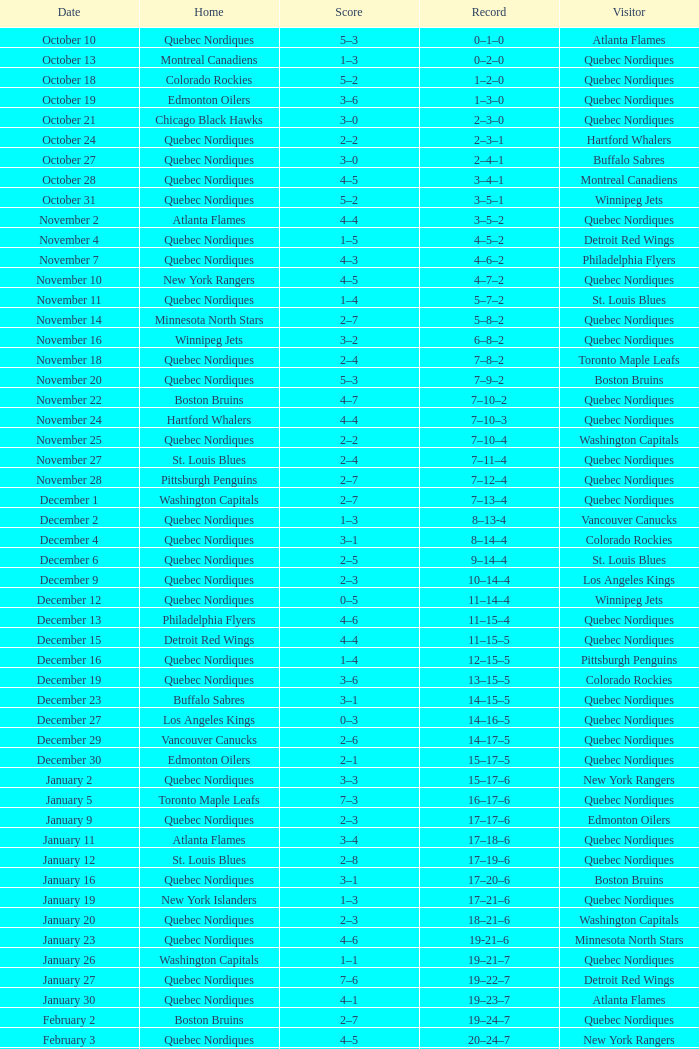Could you parse the entire table as a dict? {'header': ['Date', 'Home', 'Score', 'Record', 'Visitor'], 'rows': [['October 10', 'Quebec Nordiques', '5–3', '0–1–0', 'Atlanta Flames'], ['October 13', 'Montreal Canadiens', '1–3', '0–2–0', 'Quebec Nordiques'], ['October 18', 'Colorado Rockies', '5–2', '1–2–0', 'Quebec Nordiques'], ['October 19', 'Edmonton Oilers', '3–6', '1–3–0', 'Quebec Nordiques'], ['October 21', 'Chicago Black Hawks', '3–0', '2–3–0', 'Quebec Nordiques'], ['October 24', 'Quebec Nordiques', '2–2', '2–3–1', 'Hartford Whalers'], ['October 27', 'Quebec Nordiques', '3–0', '2–4–1', 'Buffalo Sabres'], ['October 28', 'Quebec Nordiques', '4–5', '3–4–1', 'Montreal Canadiens'], ['October 31', 'Quebec Nordiques', '5–2', '3–5–1', 'Winnipeg Jets'], ['November 2', 'Atlanta Flames', '4–4', '3–5–2', 'Quebec Nordiques'], ['November 4', 'Quebec Nordiques', '1–5', '4–5–2', 'Detroit Red Wings'], ['November 7', 'Quebec Nordiques', '4–3', '4–6–2', 'Philadelphia Flyers'], ['November 10', 'New York Rangers', '4–5', '4–7–2', 'Quebec Nordiques'], ['November 11', 'Quebec Nordiques', '1–4', '5–7–2', 'St. Louis Blues'], ['November 14', 'Minnesota North Stars', '2–7', '5–8–2', 'Quebec Nordiques'], ['November 16', 'Winnipeg Jets', '3–2', '6–8–2', 'Quebec Nordiques'], ['November 18', 'Quebec Nordiques', '2–4', '7–8–2', 'Toronto Maple Leafs'], ['November 20', 'Quebec Nordiques', '5–3', '7–9–2', 'Boston Bruins'], ['November 22', 'Boston Bruins', '4–7', '7–10–2', 'Quebec Nordiques'], ['November 24', 'Hartford Whalers', '4–4', '7–10–3', 'Quebec Nordiques'], ['November 25', 'Quebec Nordiques', '2–2', '7–10–4', 'Washington Capitals'], ['November 27', 'St. Louis Blues', '2–4', '7–11–4', 'Quebec Nordiques'], ['November 28', 'Pittsburgh Penguins', '2–7', '7–12–4', 'Quebec Nordiques'], ['December 1', 'Washington Capitals', '2–7', '7–13–4', 'Quebec Nordiques'], ['December 2', 'Quebec Nordiques', '1–3', '8–13-4', 'Vancouver Canucks'], ['December 4', 'Quebec Nordiques', '3–1', '8–14–4', 'Colorado Rockies'], ['December 6', 'Quebec Nordiques', '2–5', '9–14–4', 'St. Louis Blues'], ['December 9', 'Quebec Nordiques', '2–3', '10–14–4', 'Los Angeles Kings'], ['December 12', 'Quebec Nordiques', '0–5', '11–14–4', 'Winnipeg Jets'], ['December 13', 'Philadelphia Flyers', '4–6', '11–15–4', 'Quebec Nordiques'], ['December 15', 'Detroit Red Wings', '4–4', '11–15–5', 'Quebec Nordiques'], ['December 16', 'Quebec Nordiques', '1–4', '12–15–5', 'Pittsburgh Penguins'], ['December 19', 'Quebec Nordiques', '3–6', '13–15–5', 'Colorado Rockies'], ['December 23', 'Buffalo Sabres', '3–1', '14–15–5', 'Quebec Nordiques'], ['December 27', 'Los Angeles Kings', '0–3', '14–16–5', 'Quebec Nordiques'], ['December 29', 'Vancouver Canucks', '2–6', '14–17–5', 'Quebec Nordiques'], ['December 30', 'Edmonton Oilers', '2–1', '15–17–5', 'Quebec Nordiques'], ['January 2', 'Quebec Nordiques', '3–3', '15–17–6', 'New York Rangers'], ['January 5', 'Toronto Maple Leafs', '7–3', '16–17–6', 'Quebec Nordiques'], ['January 9', 'Quebec Nordiques', '2–3', '17–17–6', 'Edmonton Oilers'], ['January 11', 'Atlanta Flames', '3–4', '17–18–6', 'Quebec Nordiques'], ['January 12', 'St. Louis Blues', '2–8', '17–19–6', 'Quebec Nordiques'], ['January 16', 'Quebec Nordiques', '3–1', '17–20–6', 'Boston Bruins'], ['January 19', 'New York Islanders', '1–3', '17–21–6', 'Quebec Nordiques'], ['January 20', 'Quebec Nordiques', '2–3', '18–21–6', 'Washington Capitals'], ['January 23', 'Quebec Nordiques', '4–6', '19-21–6', 'Minnesota North Stars'], ['January 26', 'Washington Capitals', '1–1', '19–21–7', 'Quebec Nordiques'], ['January 27', 'Quebec Nordiques', '7–6', '19–22–7', 'Detroit Red Wings'], ['January 30', 'Quebec Nordiques', '4–1', '19–23–7', 'Atlanta Flames'], ['February 2', 'Boston Bruins', '2–7', '19–24–7', 'Quebec Nordiques'], ['February 3', 'Quebec Nordiques', '4–5', '20–24–7', 'New York Rangers'], ['February 6', 'Quebec Nordiques', '3–3', '20–24–8', 'Chicago Black Hawks'], ['February 9', 'New York Islanders', '0–5', '20–25–8', 'Quebec Nordiques'], ['February 10', 'New York Rangers', '1–3', '20–26–8', 'Quebec Nordiques'], ['February 14', 'Montreal Canadiens', '1–5', '20–27–8', 'Quebec Nordiques'], ['February 17', 'Winnipeg Jets', '5–6', '20–28–8', 'Quebec Nordiques'], ['February 18', 'Minnesota North Stars', '2–6', '20–29–8', 'Quebec Nordiques'], ['February 19', 'Quebec Nordiques', '3–1', '20–30–8', 'Buffalo Sabres'], ['February 23', 'Pittsburgh Penguins', '1–2', '20–31–8', 'Quebec Nordiques'], ['February 24', 'Quebec Nordiques', '0–2', '21–31–8', 'Pittsburgh Penguins'], ['February 26', 'Quebec Nordiques', '5–9', '22–31–8', 'Hartford Whalers'], ['February 27', 'Quebec Nordiques', '5–3', '22–32–8', 'New York Islanders'], ['March 2', 'Quebec Nordiques', '4–3', '22–33–8', 'Los Angeles Kings'], ['March 5', 'Quebec Nordiques', '3-3', '22–33–9', 'Minnesota North Stars'], ['March 8', 'Toronto Maple Leafs', '2–3', '22–34–9', 'Quebec Nordiques'], ['March 9', 'Quebec Nordiques', '4–5', '23–34-9', 'Toronto Maple Leafs'], ['March 12', 'Quebec Nordiques', '6–3', '23–35–9', 'Edmonton Oilers'], ['March 16', 'Quebec Nordiques', '3–2', '23–36–9', 'Vancouver Canucks'], ['March 19', 'Chicago Black Hawks', '2–5', '23–37–9', 'Quebec Nordiques'], ['March 20', 'Colorado Rockies', '6–2', '24–37–9', 'Quebec Nordiques'], ['March 22', 'Los Angeles Kings', '1-4', '24–38-9', 'Quebec Nordiques'], ['March 23', 'Vancouver Canucks', '6–2', '25–38–9', 'Quebec Nordiques'], ['March 26', 'Quebec Nordiques', '7–2', '25–39–9', 'Chicago Black Hawks'], ['March 27', 'Philadelphia Flyers', '2–5', '25–40–9', 'Quebec Nordiques'], ['March 29', 'Detroit Red Wings', '7–9', '25–41–9', 'Quebec Nordiques'], ['March 30', 'Quebec Nordiques', '9–6', '25–42–9', 'New York Islanders'], ['April 1', 'Quebec Nordiques', '3–3', '25–42–10', 'Philadelphia Flyers'], ['April 3', 'Buffalo Sabres', '3–8', '25–43–10', 'Quebec Nordiques'], ['April 4', 'Hartford Whalers', '2–9', '25–44–10', 'Quebec Nordiques'], ['April 6', 'Quebec Nordiques', '4–4', '25–44–11', 'Montreal Canadiens']]} Which Record has a Home of edmonton oilers, and a Score of 3–6? 1–3–0. 